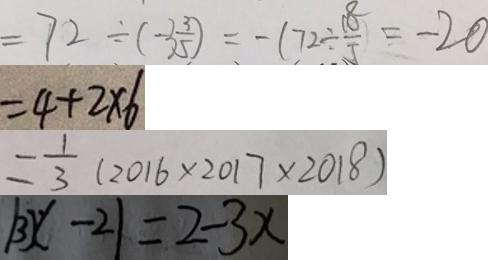<formula> <loc_0><loc_0><loc_500><loc_500>= 7 2 \div ( - 3 \frac { 3 } { 5 } ) = - ( 7 2 \div \frac { 1 8 } { 5 } ) = - 2 0 
 = 4 + 2 \times 6 
 = \frac { 1 } { 3 } ( 2 0 1 6 \times 2 0 1 7 \times 2 0 1 8 ) 
 \vert 3 x - 2 \vert = 2 - 3 x</formula> 